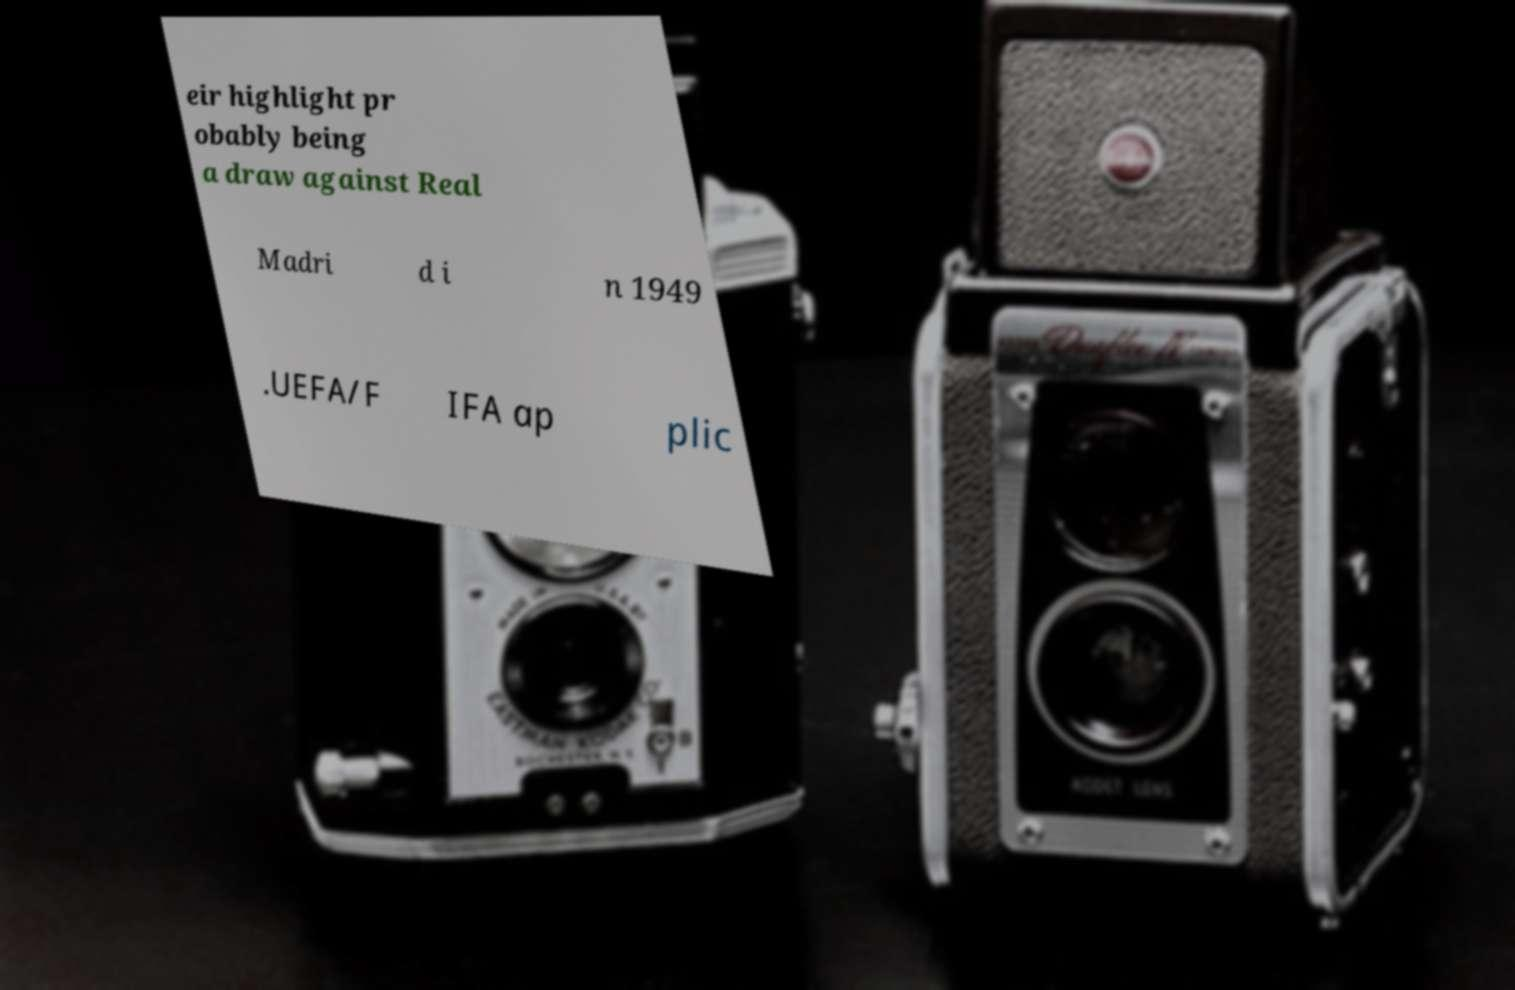Can you read and provide the text displayed in the image?This photo seems to have some interesting text. Can you extract and type it out for me? eir highlight pr obably being a draw against Real Madri d i n 1949 .UEFA/F IFA ap plic 